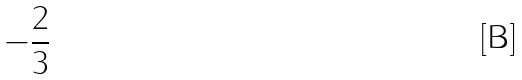Convert formula to latex. <formula><loc_0><loc_0><loc_500><loc_500>- \frac { 2 } { 3 }</formula> 